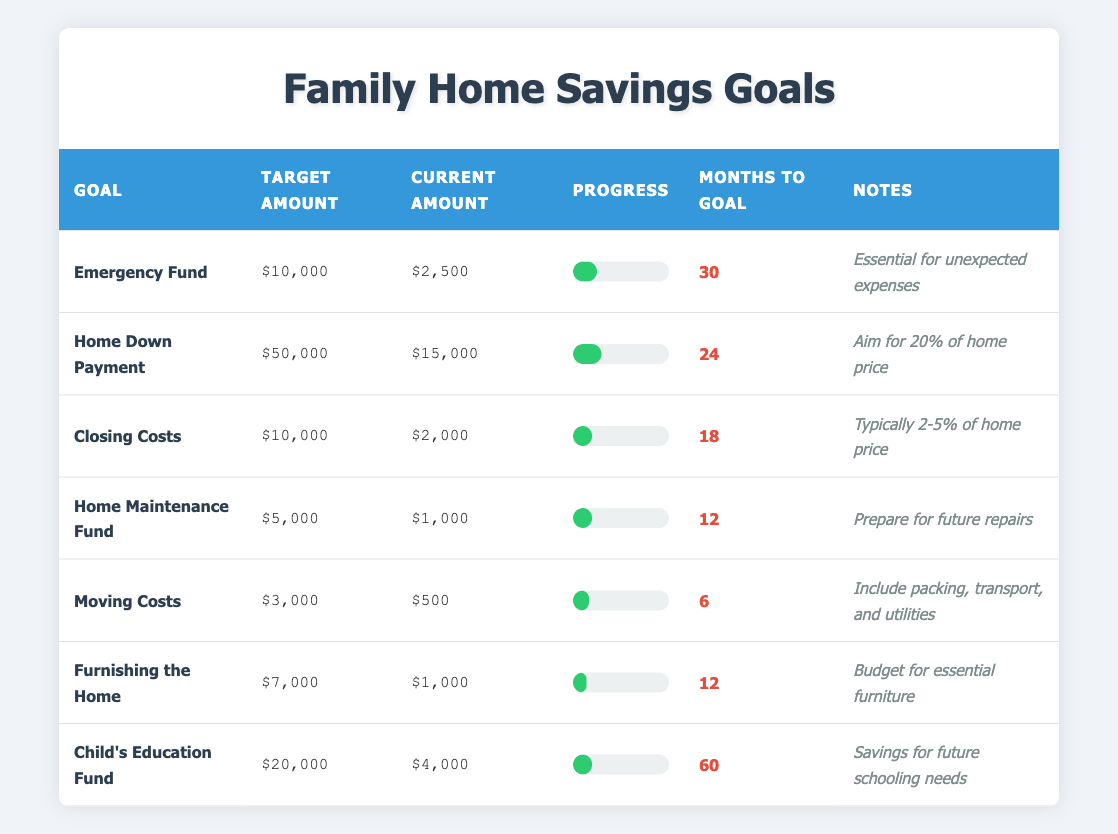What is the target amount for the Home Down Payment? The target amount for the Home Down Payment goal can be found in the corresponding row. It is listed as $50,000.
Answer: $50,000 How much has been saved towards the Moving Costs? The current amount saved for Moving Costs is listed in the table as $500.
Answer: $500 Which savings goal has the most months to reach its target? To find this, we can look through the "Months to Goal" column. The Child's Education Fund has 60 months, which is the highest.
Answer: Child's Education Fund What is the total target amount for all savings goals combined? The target amounts are summed: $10,000 (Emergency Fund) + $50,000 (Home Down Payment) + $10,000 (Closing Costs) + $5,000 (Home Maintenance Fund) + $3,000 (Moving Costs) + $7,000 (Furnishing) + $20,000 (Child’s Education Fund) = $105,000.
Answer: $105,000 Is the progress for the Home Maintenance Fund greater than the progress for the Closing Costs? The progress for the Home Maintenance Fund is at 20%, and for Closing Costs, it is also at 20%. Since they are equal, the answer is no.
Answer: No What is the difference between the target amount and the current amount for the Furnishing the Home goal? The target amount is $7,000 and the current amount is $1,000. The difference is calculated as $7,000 - $1,000 = $6,000.
Answer: $6,000 Which saving goal has the least progress towards its target? The goal with the least progress can be found by comparing the progress percentages: Moving Costs at 16.67% has the least.
Answer: Moving Costs If you want to reach your Emergency Fund goal in half the time, how much would you need to save each month? The goal is $10,000 and currently, $2,500 has been saved, requiring $7,500 more. In half the time (15 months), you need to save $7,500 / 15 = $500 per month.
Answer: $500 What percentage of the Home Down Payment target has been achieved? To find this percentage: current amount $15,000 divided by target amount $50,000, then multiplied by 100. So, ($15,000 / $50,000) * 100 = 30%.
Answer: 30% Which goal requires the least amount of savings in total? From the target amounts listed, the Moving Costs goal requires the least, at only $3,000.
Answer: Moving Costs 